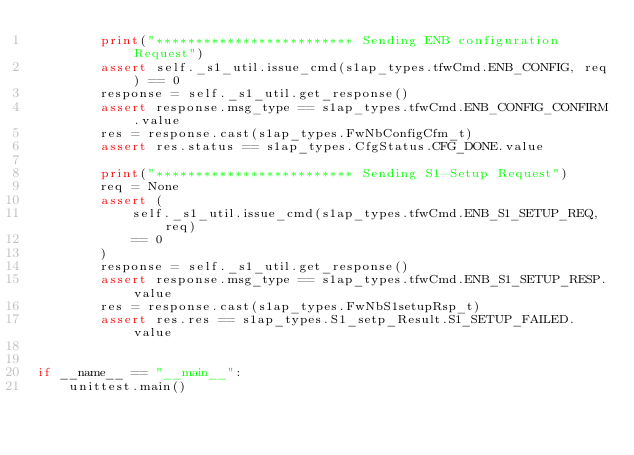Convert code to text. <code><loc_0><loc_0><loc_500><loc_500><_Python_>        print("************************* Sending ENB configuration Request")
        assert self._s1_util.issue_cmd(s1ap_types.tfwCmd.ENB_CONFIG, req) == 0
        response = self._s1_util.get_response()
        assert response.msg_type == s1ap_types.tfwCmd.ENB_CONFIG_CONFIRM.value
        res = response.cast(s1ap_types.FwNbConfigCfm_t)
        assert res.status == s1ap_types.CfgStatus.CFG_DONE.value

        print("************************* Sending S1-Setup Request")
        req = None
        assert (
            self._s1_util.issue_cmd(s1ap_types.tfwCmd.ENB_S1_SETUP_REQ, req)
            == 0
        )
        response = self._s1_util.get_response()
        assert response.msg_type == s1ap_types.tfwCmd.ENB_S1_SETUP_RESP.value
        res = response.cast(s1ap_types.FwNbS1setupRsp_t)
        assert res.res == s1ap_types.S1_setp_Result.S1_SETUP_FAILED.value


if __name__ == "__main__":
    unittest.main()
</code> 